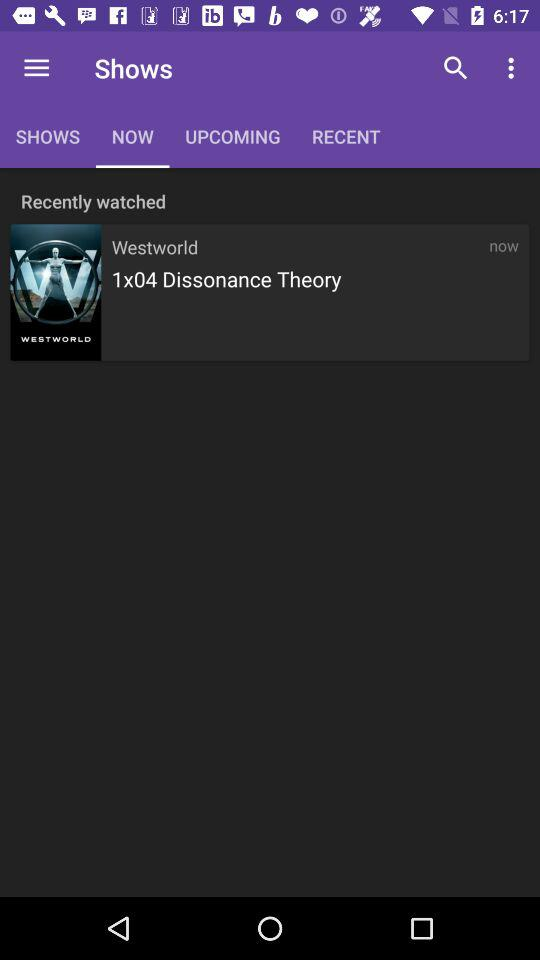Which tab am I on? You are on the "NOW" tab. 